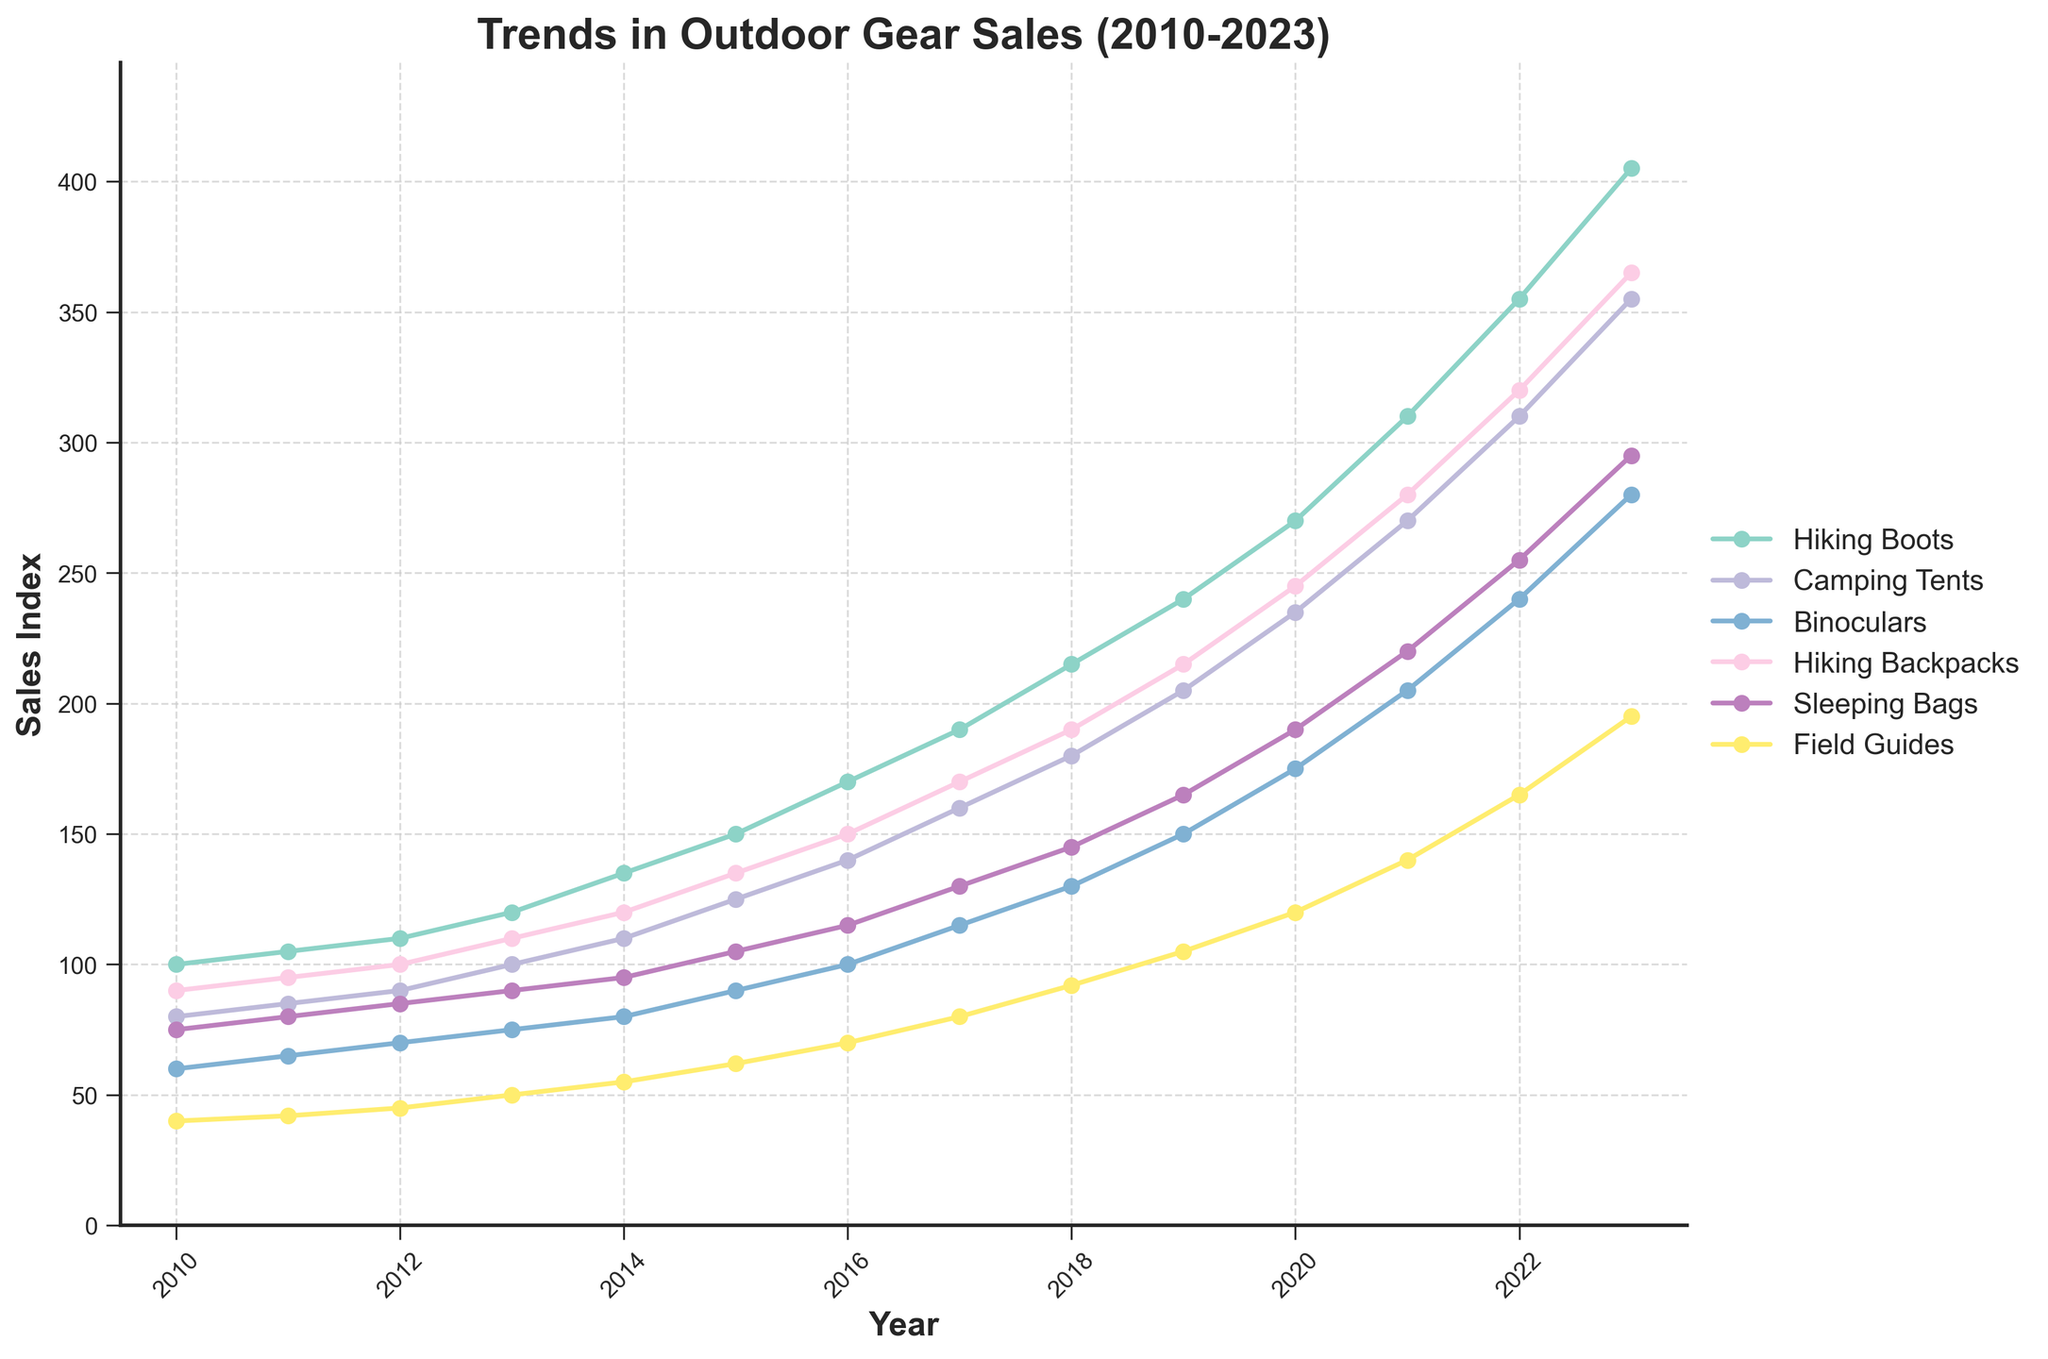What's the highest sales figure in 2023? To find the highest sales figure in 2023, look at the end of each line on the graph for 2023. Identify the one that reaches the highest point. The "Hiking Boots" category has the highest sales figure at 405.
Answer: 405 Which product category saw the most significant increase in sales from 2010 to 2023? To determine the category with the most significant increase, calculate the difference between the 2023 and 2010 sales for each category. "Hiking Boots" went from 100 to 405, the largest absolute increase of 305 units.
Answer: Hiking Boots What is the average sales figure for Camping Tents between 2010 and 2023? Add the sales figures for "Camping Tents" from 2010 to 2023 and divide by the number of years. (80 + 85 + 90 + 100 + 110 + 125 + 140 + 160 + 180 + 205 + 235 + 270 + 310 + 355) / 14 = 190.71
Answer: ~190.71 Which product category consistently had the lowest sales? Review each line on the graph to see which category remains the lowest across all years. "Field Guides" consistently stays at the bottom.
Answer: Field Guides Were there any years where the sales of Binoculars surpassed the sales of Camping Tents? Compare the height of the lines for "Binoculars" and "Camping Tents" for each year to see if "Binoculars" is higher in any year. The "Camping Tents" sales are consistently higher in all years.
Answer: No How much did sales of Sleeping Bags increase between 2012 and 2018? Subtract the 2012 sales figure for "Sleeping Bags" from the 2018 figure. (145 - 85) = 60
Answer: 60 In which year did Hiking Backpacks first exceed 200 units in sales? Look for the first year where the "Hiking Backpacks" line crosses the 200-unit mark. This occurs in 2019 with a sales figure of 215.
Answer: 2019 What are the total sales for Birdwatching equipment (Binoculars and Field Guides) in 2023? Add the sales figures for "Binoculars" and "Field Guides" for the year 2023. (280 + 195) = 475
Answer: 475 Which product category had the steepest growth between 2020 and 2023? Calculate the growth for each category between 2020 and 2023, then identify the highest one. "Hiking Boots" grew from 270 to 405, which is the largest increase of 135 units.
Answer: Hiking Boots Compare the sales of Hiking Backpacks and Sleeping Bags in 2021. Which one was higher and by how much? Find the sales figures for both categories in 2021 and subtract the lower from the higher. "Hiking Backpacks" had 280, and "Sleeping Bags" had 220, hence the difference is 60.
Answer: Hiking Backpacks by 60 